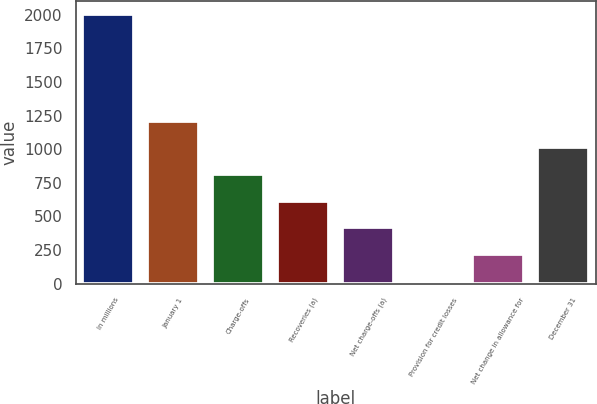Convert chart. <chart><loc_0><loc_0><loc_500><loc_500><bar_chart><fcel>In millions<fcel>January 1<fcel>Charge-offs<fcel>Recoveries (a)<fcel>Net charge-offs (a)<fcel>Provision for credit losses<fcel>Net change in allowance for<fcel>December 31<nl><fcel>2005<fcel>1211.4<fcel>814.6<fcel>616.2<fcel>417.8<fcel>21<fcel>219.4<fcel>1013<nl></chart> 